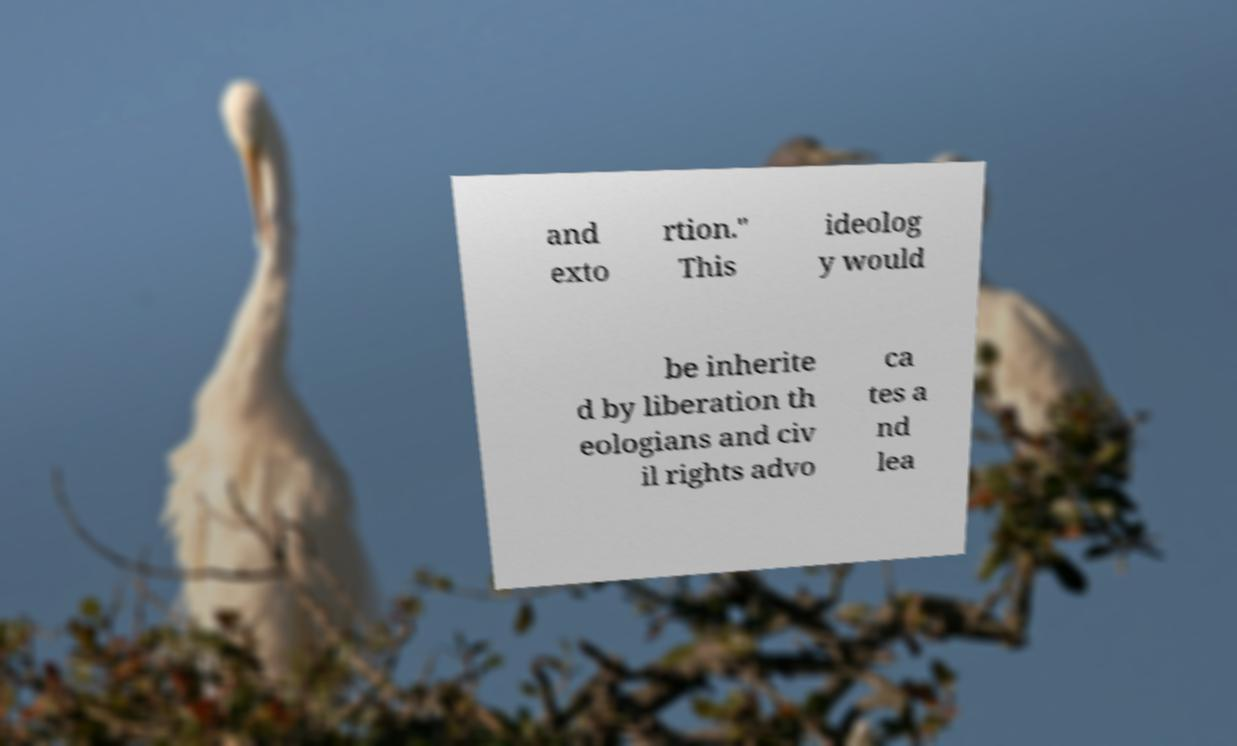Could you assist in decoding the text presented in this image and type it out clearly? and exto rtion." This ideolog y would be inherite d by liberation th eologians and civ il rights advo ca tes a nd lea 